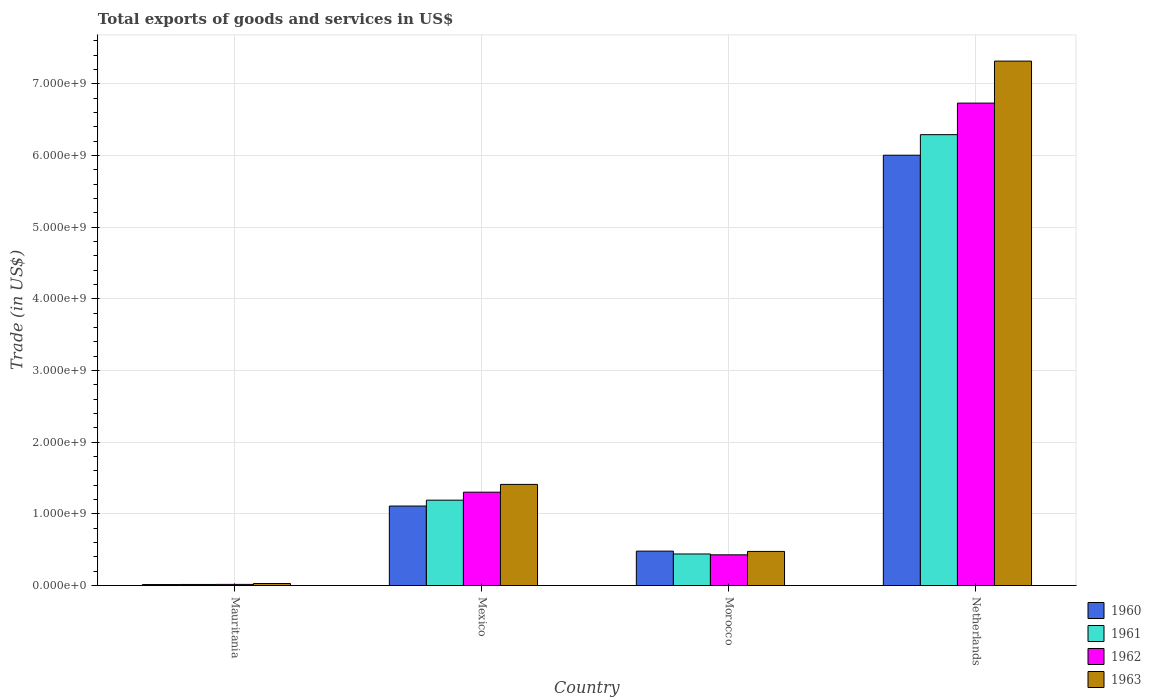How many different coloured bars are there?
Keep it short and to the point. 4. How many groups of bars are there?
Ensure brevity in your answer.  4. Are the number of bars per tick equal to the number of legend labels?
Give a very brief answer. Yes. Are the number of bars on each tick of the X-axis equal?
Ensure brevity in your answer.  Yes. How many bars are there on the 3rd tick from the left?
Your response must be concise. 4. What is the label of the 4th group of bars from the left?
Offer a very short reply. Netherlands. What is the total exports of goods and services in 1963 in Morocco?
Make the answer very short. 4.76e+08. Across all countries, what is the maximum total exports of goods and services in 1963?
Offer a very short reply. 7.32e+09. Across all countries, what is the minimum total exports of goods and services in 1961?
Offer a very short reply. 1.54e+07. In which country was the total exports of goods and services in 1963 maximum?
Provide a succinct answer. Netherlands. In which country was the total exports of goods and services in 1960 minimum?
Give a very brief answer. Mauritania. What is the total total exports of goods and services in 1962 in the graph?
Keep it short and to the point. 8.48e+09. What is the difference between the total exports of goods and services in 1961 in Mexico and that in Morocco?
Give a very brief answer. 7.51e+08. What is the difference between the total exports of goods and services in 1963 in Mauritania and the total exports of goods and services in 1960 in Mexico?
Provide a short and direct response. -1.08e+09. What is the average total exports of goods and services in 1962 per country?
Provide a succinct answer. 2.12e+09. What is the difference between the total exports of goods and services of/in 1960 and total exports of goods and services of/in 1962 in Mexico?
Give a very brief answer. -1.93e+08. In how many countries, is the total exports of goods and services in 1960 greater than 400000000 US$?
Ensure brevity in your answer.  3. What is the ratio of the total exports of goods and services in 1960 in Mauritania to that in Morocco?
Your response must be concise. 0.03. Is the total exports of goods and services in 1962 in Mexico less than that in Netherlands?
Your answer should be compact. Yes. Is the difference between the total exports of goods and services in 1960 in Mexico and Netherlands greater than the difference between the total exports of goods and services in 1962 in Mexico and Netherlands?
Keep it short and to the point. Yes. What is the difference between the highest and the second highest total exports of goods and services in 1962?
Give a very brief answer. 8.74e+08. What is the difference between the highest and the lowest total exports of goods and services in 1961?
Give a very brief answer. 6.27e+09. What does the 2nd bar from the left in Mauritania represents?
Offer a very short reply. 1961. What does the 4th bar from the right in Mauritania represents?
Keep it short and to the point. 1960. Is it the case that in every country, the sum of the total exports of goods and services in 1963 and total exports of goods and services in 1962 is greater than the total exports of goods and services in 1960?
Your answer should be very brief. Yes. How many countries are there in the graph?
Ensure brevity in your answer.  4. Does the graph contain any zero values?
Your answer should be very brief. No. Where does the legend appear in the graph?
Your answer should be compact. Bottom right. How many legend labels are there?
Ensure brevity in your answer.  4. What is the title of the graph?
Provide a short and direct response. Total exports of goods and services in US$. Does "1971" appear as one of the legend labels in the graph?
Offer a terse response. No. What is the label or title of the Y-axis?
Your response must be concise. Trade (in US$). What is the Trade (in US$) of 1960 in Mauritania?
Keep it short and to the point. 1.41e+07. What is the Trade (in US$) in 1961 in Mauritania?
Your answer should be very brief. 1.54e+07. What is the Trade (in US$) in 1962 in Mauritania?
Provide a succinct answer. 1.62e+07. What is the Trade (in US$) of 1963 in Mauritania?
Offer a very short reply. 2.87e+07. What is the Trade (in US$) of 1960 in Mexico?
Ensure brevity in your answer.  1.11e+09. What is the Trade (in US$) of 1961 in Mexico?
Give a very brief answer. 1.19e+09. What is the Trade (in US$) of 1962 in Mexico?
Offer a very short reply. 1.30e+09. What is the Trade (in US$) in 1963 in Mexico?
Provide a short and direct response. 1.41e+09. What is the Trade (in US$) in 1960 in Morocco?
Your answer should be very brief. 4.80e+08. What is the Trade (in US$) in 1961 in Morocco?
Offer a terse response. 4.41e+08. What is the Trade (in US$) of 1962 in Morocco?
Your response must be concise. 4.29e+08. What is the Trade (in US$) of 1963 in Morocco?
Offer a very short reply. 4.76e+08. What is the Trade (in US$) of 1960 in Netherlands?
Make the answer very short. 6.00e+09. What is the Trade (in US$) in 1961 in Netherlands?
Give a very brief answer. 6.29e+09. What is the Trade (in US$) of 1962 in Netherlands?
Offer a very short reply. 6.73e+09. What is the Trade (in US$) in 1963 in Netherlands?
Offer a very short reply. 7.32e+09. Across all countries, what is the maximum Trade (in US$) in 1960?
Provide a succinct answer. 6.00e+09. Across all countries, what is the maximum Trade (in US$) in 1961?
Your answer should be very brief. 6.29e+09. Across all countries, what is the maximum Trade (in US$) of 1962?
Offer a very short reply. 6.73e+09. Across all countries, what is the maximum Trade (in US$) of 1963?
Your answer should be compact. 7.32e+09. Across all countries, what is the minimum Trade (in US$) in 1960?
Provide a short and direct response. 1.41e+07. Across all countries, what is the minimum Trade (in US$) of 1961?
Your answer should be very brief. 1.54e+07. Across all countries, what is the minimum Trade (in US$) of 1962?
Provide a short and direct response. 1.62e+07. Across all countries, what is the minimum Trade (in US$) of 1963?
Your answer should be compact. 2.87e+07. What is the total Trade (in US$) in 1960 in the graph?
Your answer should be very brief. 7.61e+09. What is the total Trade (in US$) in 1961 in the graph?
Your answer should be very brief. 7.94e+09. What is the total Trade (in US$) in 1962 in the graph?
Offer a very short reply. 8.48e+09. What is the total Trade (in US$) in 1963 in the graph?
Give a very brief answer. 9.23e+09. What is the difference between the Trade (in US$) in 1960 in Mauritania and that in Mexico?
Offer a very short reply. -1.09e+09. What is the difference between the Trade (in US$) of 1961 in Mauritania and that in Mexico?
Your response must be concise. -1.18e+09. What is the difference between the Trade (in US$) of 1962 in Mauritania and that in Mexico?
Provide a short and direct response. -1.29e+09. What is the difference between the Trade (in US$) in 1963 in Mauritania and that in Mexico?
Give a very brief answer. -1.38e+09. What is the difference between the Trade (in US$) in 1960 in Mauritania and that in Morocco?
Ensure brevity in your answer.  -4.66e+08. What is the difference between the Trade (in US$) of 1961 in Mauritania and that in Morocco?
Give a very brief answer. -4.25e+08. What is the difference between the Trade (in US$) in 1962 in Mauritania and that in Morocco?
Give a very brief answer. -4.13e+08. What is the difference between the Trade (in US$) of 1963 in Mauritania and that in Morocco?
Provide a succinct answer. -4.48e+08. What is the difference between the Trade (in US$) of 1960 in Mauritania and that in Netherlands?
Provide a succinct answer. -5.99e+09. What is the difference between the Trade (in US$) of 1961 in Mauritania and that in Netherlands?
Your answer should be compact. -6.27e+09. What is the difference between the Trade (in US$) in 1962 in Mauritania and that in Netherlands?
Your answer should be compact. -6.71e+09. What is the difference between the Trade (in US$) in 1963 in Mauritania and that in Netherlands?
Your response must be concise. -7.29e+09. What is the difference between the Trade (in US$) of 1960 in Mexico and that in Morocco?
Your response must be concise. 6.29e+08. What is the difference between the Trade (in US$) of 1961 in Mexico and that in Morocco?
Ensure brevity in your answer.  7.51e+08. What is the difference between the Trade (in US$) of 1962 in Mexico and that in Morocco?
Offer a terse response. 8.74e+08. What is the difference between the Trade (in US$) in 1963 in Mexico and that in Morocco?
Your response must be concise. 9.35e+08. What is the difference between the Trade (in US$) in 1960 in Mexico and that in Netherlands?
Your answer should be very brief. -4.89e+09. What is the difference between the Trade (in US$) of 1961 in Mexico and that in Netherlands?
Ensure brevity in your answer.  -5.10e+09. What is the difference between the Trade (in US$) of 1962 in Mexico and that in Netherlands?
Your response must be concise. -5.43e+09. What is the difference between the Trade (in US$) in 1963 in Mexico and that in Netherlands?
Provide a short and direct response. -5.90e+09. What is the difference between the Trade (in US$) in 1960 in Morocco and that in Netherlands?
Give a very brief answer. -5.52e+09. What is the difference between the Trade (in US$) of 1961 in Morocco and that in Netherlands?
Ensure brevity in your answer.  -5.85e+09. What is the difference between the Trade (in US$) of 1962 in Morocco and that in Netherlands?
Make the answer very short. -6.30e+09. What is the difference between the Trade (in US$) of 1963 in Morocco and that in Netherlands?
Give a very brief answer. -6.84e+09. What is the difference between the Trade (in US$) in 1960 in Mauritania and the Trade (in US$) in 1961 in Mexico?
Your answer should be very brief. -1.18e+09. What is the difference between the Trade (in US$) of 1960 in Mauritania and the Trade (in US$) of 1962 in Mexico?
Offer a very short reply. -1.29e+09. What is the difference between the Trade (in US$) of 1960 in Mauritania and the Trade (in US$) of 1963 in Mexico?
Your response must be concise. -1.40e+09. What is the difference between the Trade (in US$) of 1961 in Mauritania and the Trade (in US$) of 1962 in Mexico?
Give a very brief answer. -1.29e+09. What is the difference between the Trade (in US$) in 1961 in Mauritania and the Trade (in US$) in 1963 in Mexico?
Offer a very short reply. -1.40e+09. What is the difference between the Trade (in US$) in 1962 in Mauritania and the Trade (in US$) in 1963 in Mexico?
Offer a terse response. -1.39e+09. What is the difference between the Trade (in US$) of 1960 in Mauritania and the Trade (in US$) of 1961 in Morocco?
Provide a succinct answer. -4.27e+08. What is the difference between the Trade (in US$) in 1960 in Mauritania and the Trade (in US$) in 1962 in Morocco?
Provide a succinct answer. -4.15e+08. What is the difference between the Trade (in US$) of 1960 in Mauritania and the Trade (in US$) of 1963 in Morocco?
Your answer should be compact. -4.62e+08. What is the difference between the Trade (in US$) of 1961 in Mauritania and the Trade (in US$) of 1962 in Morocco?
Give a very brief answer. -4.13e+08. What is the difference between the Trade (in US$) in 1961 in Mauritania and the Trade (in US$) in 1963 in Morocco?
Your answer should be very brief. -4.61e+08. What is the difference between the Trade (in US$) of 1962 in Mauritania and the Trade (in US$) of 1963 in Morocco?
Give a very brief answer. -4.60e+08. What is the difference between the Trade (in US$) in 1960 in Mauritania and the Trade (in US$) in 1961 in Netherlands?
Ensure brevity in your answer.  -6.27e+09. What is the difference between the Trade (in US$) in 1960 in Mauritania and the Trade (in US$) in 1962 in Netherlands?
Give a very brief answer. -6.72e+09. What is the difference between the Trade (in US$) of 1960 in Mauritania and the Trade (in US$) of 1963 in Netherlands?
Offer a very short reply. -7.30e+09. What is the difference between the Trade (in US$) in 1961 in Mauritania and the Trade (in US$) in 1962 in Netherlands?
Give a very brief answer. -6.71e+09. What is the difference between the Trade (in US$) in 1961 in Mauritania and the Trade (in US$) in 1963 in Netherlands?
Give a very brief answer. -7.30e+09. What is the difference between the Trade (in US$) of 1962 in Mauritania and the Trade (in US$) of 1963 in Netherlands?
Ensure brevity in your answer.  -7.30e+09. What is the difference between the Trade (in US$) in 1960 in Mexico and the Trade (in US$) in 1961 in Morocco?
Ensure brevity in your answer.  6.68e+08. What is the difference between the Trade (in US$) of 1960 in Mexico and the Trade (in US$) of 1962 in Morocco?
Provide a succinct answer. 6.80e+08. What is the difference between the Trade (in US$) of 1960 in Mexico and the Trade (in US$) of 1963 in Morocco?
Make the answer very short. 6.33e+08. What is the difference between the Trade (in US$) of 1961 in Mexico and the Trade (in US$) of 1962 in Morocco?
Provide a succinct answer. 7.62e+08. What is the difference between the Trade (in US$) of 1961 in Mexico and the Trade (in US$) of 1963 in Morocco?
Make the answer very short. 7.15e+08. What is the difference between the Trade (in US$) in 1962 in Mexico and the Trade (in US$) in 1963 in Morocco?
Your answer should be compact. 8.26e+08. What is the difference between the Trade (in US$) of 1960 in Mexico and the Trade (in US$) of 1961 in Netherlands?
Your answer should be compact. -5.18e+09. What is the difference between the Trade (in US$) in 1960 in Mexico and the Trade (in US$) in 1962 in Netherlands?
Provide a succinct answer. -5.62e+09. What is the difference between the Trade (in US$) of 1960 in Mexico and the Trade (in US$) of 1963 in Netherlands?
Offer a terse response. -6.21e+09. What is the difference between the Trade (in US$) in 1961 in Mexico and the Trade (in US$) in 1962 in Netherlands?
Your response must be concise. -5.54e+09. What is the difference between the Trade (in US$) in 1961 in Mexico and the Trade (in US$) in 1963 in Netherlands?
Make the answer very short. -6.12e+09. What is the difference between the Trade (in US$) of 1962 in Mexico and the Trade (in US$) of 1963 in Netherlands?
Give a very brief answer. -6.01e+09. What is the difference between the Trade (in US$) of 1960 in Morocco and the Trade (in US$) of 1961 in Netherlands?
Offer a terse response. -5.81e+09. What is the difference between the Trade (in US$) of 1960 in Morocco and the Trade (in US$) of 1962 in Netherlands?
Provide a short and direct response. -6.25e+09. What is the difference between the Trade (in US$) in 1960 in Morocco and the Trade (in US$) in 1963 in Netherlands?
Make the answer very short. -6.83e+09. What is the difference between the Trade (in US$) in 1961 in Morocco and the Trade (in US$) in 1962 in Netherlands?
Make the answer very short. -6.29e+09. What is the difference between the Trade (in US$) in 1961 in Morocco and the Trade (in US$) in 1963 in Netherlands?
Make the answer very short. -6.87e+09. What is the difference between the Trade (in US$) in 1962 in Morocco and the Trade (in US$) in 1963 in Netherlands?
Keep it short and to the point. -6.89e+09. What is the average Trade (in US$) in 1960 per country?
Offer a terse response. 1.90e+09. What is the average Trade (in US$) in 1961 per country?
Provide a succinct answer. 1.98e+09. What is the average Trade (in US$) in 1962 per country?
Offer a very short reply. 2.12e+09. What is the average Trade (in US$) of 1963 per country?
Keep it short and to the point. 2.31e+09. What is the difference between the Trade (in US$) of 1960 and Trade (in US$) of 1961 in Mauritania?
Provide a short and direct response. -1.31e+06. What is the difference between the Trade (in US$) of 1960 and Trade (in US$) of 1962 in Mauritania?
Offer a very short reply. -2.02e+06. What is the difference between the Trade (in US$) in 1960 and Trade (in US$) in 1963 in Mauritania?
Offer a very short reply. -1.45e+07. What is the difference between the Trade (in US$) in 1961 and Trade (in US$) in 1962 in Mauritania?
Your answer should be very brief. -7.07e+05. What is the difference between the Trade (in US$) in 1961 and Trade (in US$) in 1963 in Mauritania?
Offer a terse response. -1.32e+07. What is the difference between the Trade (in US$) in 1962 and Trade (in US$) in 1963 in Mauritania?
Your answer should be very brief. -1.25e+07. What is the difference between the Trade (in US$) of 1960 and Trade (in US$) of 1961 in Mexico?
Ensure brevity in your answer.  -8.21e+07. What is the difference between the Trade (in US$) of 1960 and Trade (in US$) of 1962 in Mexico?
Your answer should be very brief. -1.93e+08. What is the difference between the Trade (in US$) in 1960 and Trade (in US$) in 1963 in Mexico?
Ensure brevity in your answer.  -3.02e+08. What is the difference between the Trade (in US$) in 1961 and Trade (in US$) in 1962 in Mexico?
Ensure brevity in your answer.  -1.11e+08. What is the difference between the Trade (in US$) in 1961 and Trade (in US$) in 1963 in Mexico?
Your response must be concise. -2.20e+08. What is the difference between the Trade (in US$) in 1962 and Trade (in US$) in 1963 in Mexico?
Provide a succinct answer. -1.09e+08. What is the difference between the Trade (in US$) of 1960 and Trade (in US$) of 1961 in Morocco?
Provide a short and direct response. 3.95e+07. What is the difference between the Trade (in US$) of 1960 and Trade (in US$) of 1962 in Morocco?
Keep it short and to the point. 5.14e+07. What is the difference between the Trade (in US$) of 1960 and Trade (in US$) of 1963 in Morocco?
Your response must be concise. 3.95e+06. What is the difference between the Trade (in US$) of 1961 and Trade (in US$) of 1962 in Morocco?
Keep it short and to the point. 1.19e+07. What is the difference between the Trade (in US$) of 1961 and Trade (in US$) of 1963 in Morocco?
Your answer should be compact. -3.56e+07. What is the difference between the Trade (in US$) of 1962 and Trade (in US$) of 1963 in Morocco?
Provide a short and direct response. -4.74e+07. What is the difference between the Trade (in US$) of 1960 and Trade (in US$) of 1961 in Netherlands?
Offer a terse response. -2.87e+08. What is the difference between the Trade (in US$) in 1960 and Trade (in US$) in 1962 in Netherlands?
Give a very brief answer. -7.27e+08. What is the difference between the Trade (in US$) of 1960 and Trade (in US$) of 1963 in Netherlands?
Your answer should be very brief. -1.31e+09. What is the difference between the Trade (in US$) in 1961 and Trade (in US$) in 1962 in Netherlands?
Provide a short and direct response. -4.40e+08. What is the difference between the Trade (in US$) of 1961 and Trade (in US$) of 1963 in Netherlands?
Provide a short and direct response. -1.03e+09. What is the difference between the Trade (in US$) of 1962 and Trade (in US$) of 1963 in Netherlands?
Your answer should be very brief. -5.86e+08. What is the ratio of the Trade (in US$) of 1960 in Mauritania to that in Mexico?
Make the answer very short. 0.01. What is the ratio of the Trade (in US$) of 1961 in Mauritania to that in Mexico?
Provide a succinct answer. 0.01. What is the ratio of the Trade (in US$) in 1962 in Mauritania to that in Mexico?
Your answer should be compact. 0.01. What is the ratio of the Trade (in US$) of 1963 in Mauritania to that in Mexico?
Ensure brevity in your answer.  0.02. What is the ratio of the Trade (in US$) of 1960 in Mauritania to that in Morocco?
Provide a short and direct response. 0.03. What is the ratio of the Trade (in US$) in 1961 in Mauritania to that in Morocco?
Your response must be concise. 0.04. What is the ratio of the Trade (in US$) of 1962 in Mauritania to that in Morocco?
Give a very brief answer. 0.04. What is the ratio of the Trade (in US$) in 1963 in Mauritania to that in Morocco?
Provide a short and direct response. 0.06. What is the ratio of the Trade (in US$) of 1960 in Mauritania to that in Netherlands?
Your answer should be compact. 0. What is the ratio of the Trade (in US$) of 1961 in Mauritania to that in Netherlands?
Offer a terse response. 0. What is the ratio of the Trade (in US$) of 1962 in Mauritania to that in Netherlands?
Offer a terse response. 0. What is the ratio of the Trade (in US$) of 1963 in Mauritania to that in Netherlands?
Provide a short and direct response. 0. What is the ratio of the Trade (in US$) of 1960 in Mexico to that in Morocco?
Ensure brevity in your answer.  2.31. What is the ratio of the Trade (in US$) of 1961 in Mexico to that in Morocco?
Give a very brief answer. 2.7. What is the ratio of the Trade (in US$) of 1962 in Mexico to that in Morocco?
Keep it short and to the point. 3.04. What is the ratio of the Trade (in US$) of 1963 in Mexico to that in Morocco?
Your answer should be compact. 2.96. What is the ratio of the Trade (in US$) of 1960 in Mexico to that in Netherlands?
Your answer should be compact. 0.18. What is the ratio of the Trade (in US$) of 1961 in Mexico to that in Netherlands?
Provide a short and direct response. 0.19. What is the ratio of the Trade (in US$) of 1962 in Mexico to that in Netherlands?
Your answer should be very brief. 0.19. What is the ratio of the Trade (in US$) in 1963 in Mexico to that in Netherlands?
Offer a terse response. 0.19. What is the ratio of the Trade (in US$) of 1960 in Morocco to that in Netherlands?
Offer a very short reply. 0.08. What is the ratio of the Trade (in US$) in 1961 in Morocco to that in Netherlands?
Give a very brief answer. 0.07. What is the ratio of the Trade (in US$) of 1962 in Morocco to that in Netherlands?
Offer a very short reply. 0.06. What is the ratio of the Trade (in US$) in 1963 in Morocco to that in Netherlands?
Offer a very short reply. 0.07. What is the difference between the highest and the second highest Trade (in US$) of 1960?
Offer a terse response. 4.89e+09. What is the difference between the highest and the second highest Trade (in US$) in 1961?
Your answer should be very brief. 5.10e+09. What is the difference between the highest and the second highest Trade (in US$) of 1962?
Make the answer very short. 5.43e+09. What is the difference between the highest and the second highest Trade (in US$) of 1963?
Provide a succinct answer. 5.90e+09. What is the difference between the highest and the lowest Trade (in US$) of 1960?
Your answer should be compact. 5.99e+09. What is the difference between the highest and the lowest Trade (in US$) in 1961?
Keep it short and to the point. 6.27e+09. What is the difference between the highest and the lowest Trade (in US$) of 1962?
Ensure brevity in your answer.  6.71e+09. What is the difference between the highest and the lowest Trade (in US$) of 1963?
Ensure brevity in your answer.  7.29e+09. 